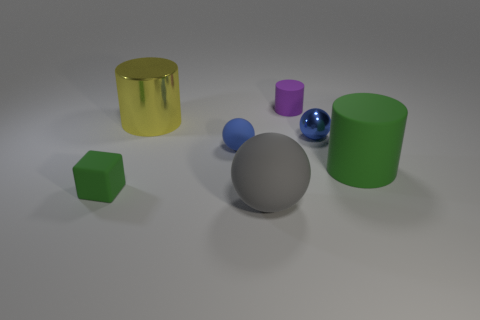Add 1 red cylinders. How many objects exist? 8 Subtract all cubes. How many objects are left? 6 Subtract 1 green cylinders. How many objects are left? 6 Subtract all red matte spheres. Subtract all big gray things. How many objects are left? 6 Add 7 small matte things. How many small matte things are left? 10 Add 4 big green metal spheres. How many big green metal spheres exist? 4 